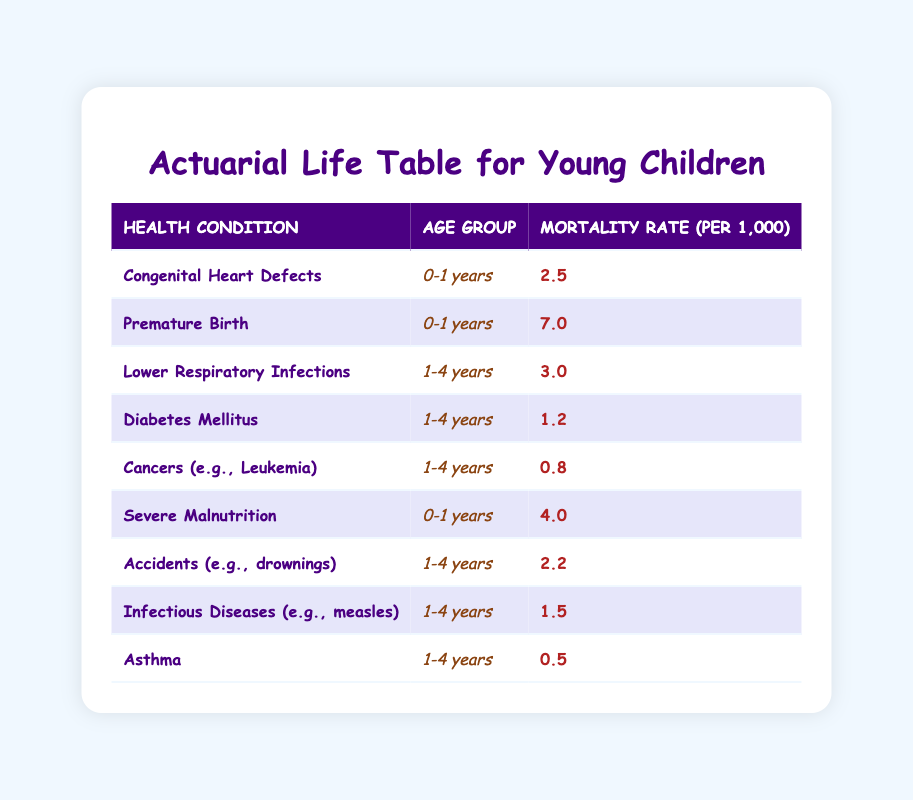What is the mortality rate for congenital heart defects in infants? The table shows that the mortality rate for congenital heart defects for the age group 0-1 years is 2.5 per 1,000.
Answer: 2.5 Which health condition has the highest mortality rate in the 0-1 year age group? According to the table, the highest mortality rate in the 0-1 years age group is from premature birth, which has a rate of 7.0 per 1,000.
Answer: Premature Birth What is the total mortality rate for children aged 1-4 years? To find the total mortality rate for the 1-4 years age group, we need to add the mortality rates of lower respiratory infections (3.0), diabetes mellitus (1.2), cancers (0.8), accidents (2.2), infectious diseases (1.5), and asthma (0.5). This gives us a total of 3.0 + 1.2 + 0.8 + 2.2 + 1.5 + 0.5 = 9.2 per 1,000.
Answer: 9.2 Is the mortality rate for severe malnutrition higher than that for diabetes mellitus in the 0-1 year age group? The table indicates that severe malnutrition has a mortality rate of 4.0 per 1,000 while diabetes mellitus is not listed for the 0-1 years age group, indicating it is not applicable here. Therefore, yes, the rate for severe malnutrition is higher.
Answer: Yes What is the average mortality rate for all listed health conditions in children aged 1-4 years? The health conditions for the 1-4 years age group are lower respiratory infections (3.0), diabetes mellitus (1.2), cancers (0.8), accidents (2.2), infectious diseases (1.5), and asthma (0.5). Adding these rates gives us a total of 3.0 + 1.2 + 0.8 + 2.2 + 1.5 + 0.5 = 9.2. There are 6 data points, so we divide the total by the number of conditions: 9.2 / 6 = 1.53.
Answer: 1.53 How does the mortality rate of asthma compare to that of lower respiratory infections in children aged 1-4 years? From the table, asthma has a mortality rate of 0.5 per 1,000, whereas lower respiratory infections have a rate of 3.0 per 1,000. Since 0.5 is less than 3.0, asthma has a lower mortality rate compared to lower respiratory infections.
Answer: Asthma has a lower mortality rate 